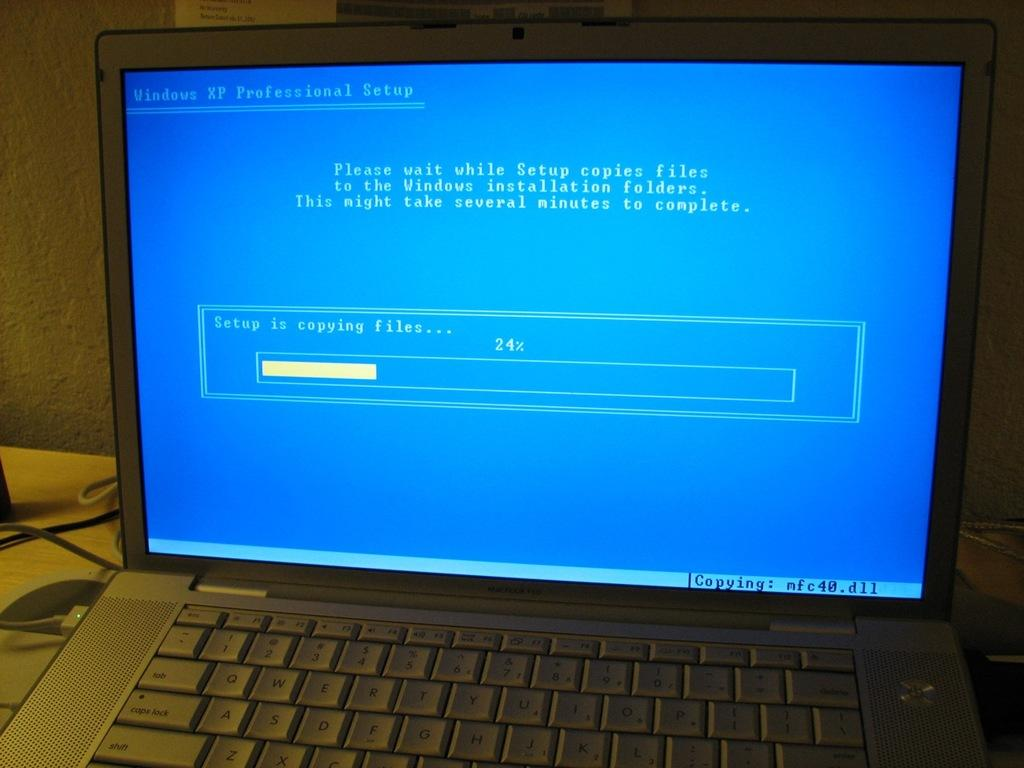<image>
Describe the image concisely. a lap top with a screen reading Windows XP Professional Setup 